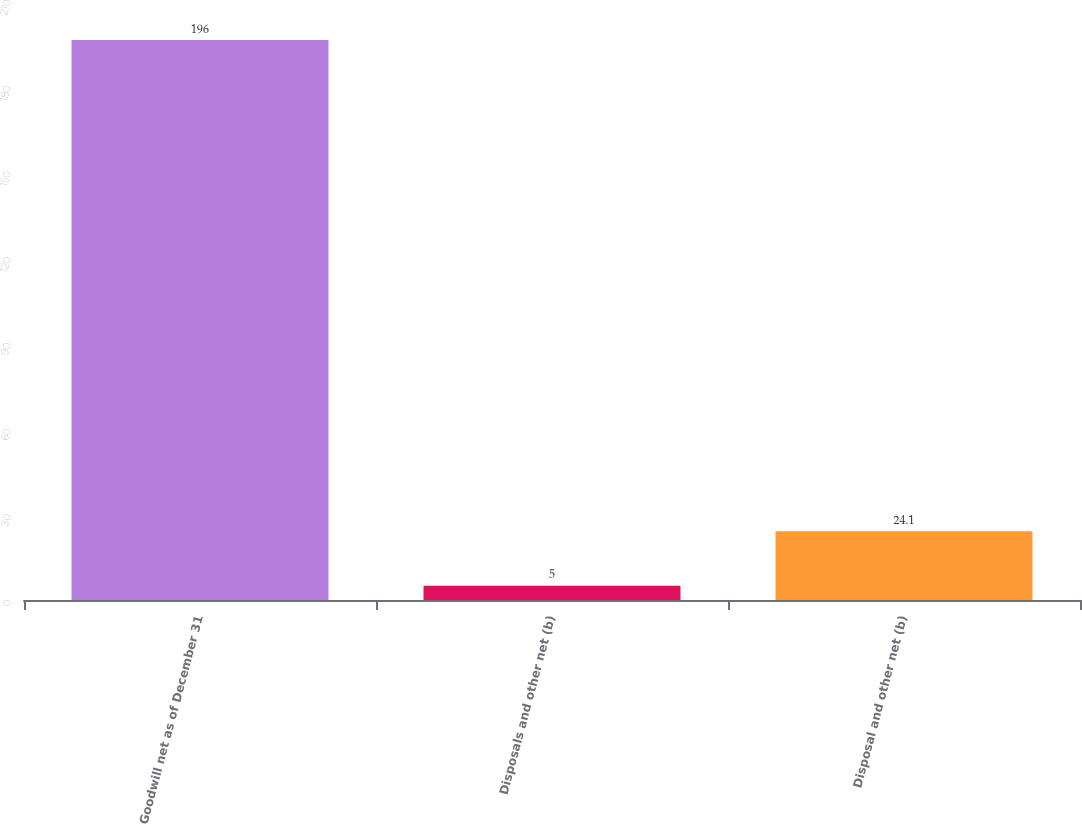<chart> <loc_0><loc_0><loc_500><loc_500><bar_chart><fcel>Goodwill net as of December 31<fcel>Disposals and other net (b)<fcel>Disposal and other net (b)<nl><fcel>196<fcel>5<fcel>24.1<nl></chart> 